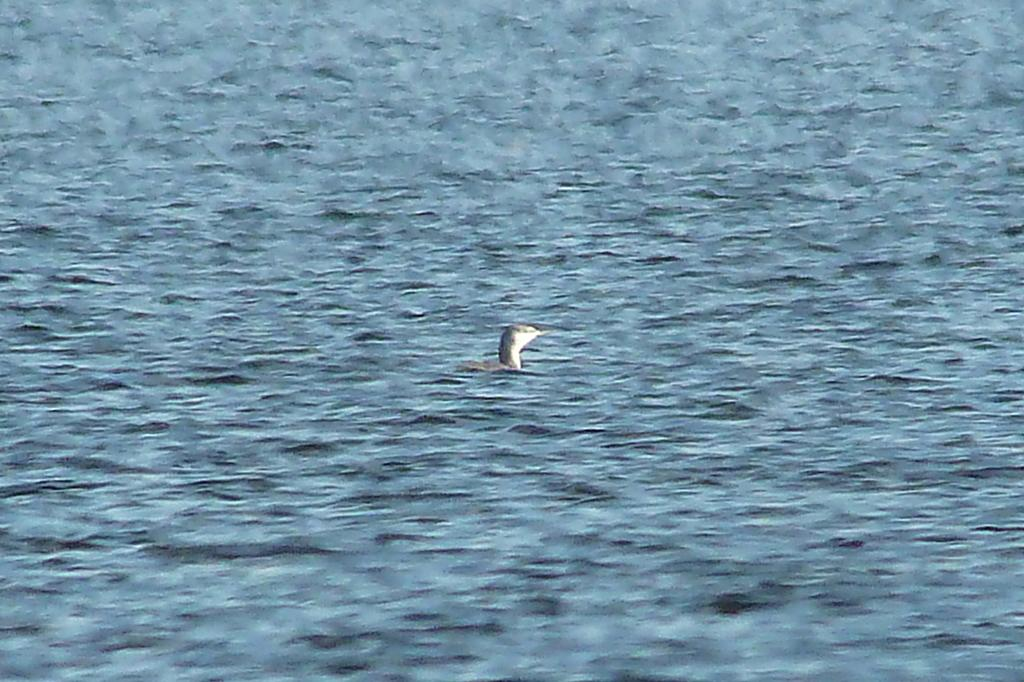What type of animal can be seen in the image? There is a bird in the image. Where is the bird located in the image? The bird is in the water. What type of spark can be seen coming from the bird's feathers in the image? There is no spark present in the image; it features a bird in the water. What emotion does the bird appear to be experiencing in the image? The image does not convey any emotions, as it is a photograph of a bird in the water. 